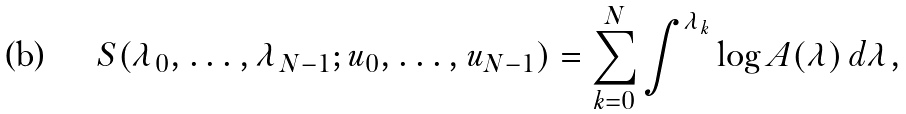Convert formula to latex. <formula><loc_0><loc_0><loc_500><loc_500>S ( \lambda _ { 0 } , \dots , \lambda _ { N - 1 } ; u _ { 0 } , \dots , u _ { N - 1 } ) = \sum _ { k = 0 } ^ { N } \int ^ { \lambda _ { k } } \log A ( \lambda ) \, d \lambda ,</formula> 